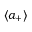<formula> <loc_0><loc_0><loc_500><loc_500>{ \langle a _ { + } \rangle }</formula> 